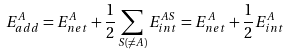<formula> <loc_0><loc_0><loc_500><loc_500>E _ { a d d } ^ { A } = E _ { n e t } ^ { A } + \frac { 1 } { 2 } \sum _ { S ( \not = A ) } E _ { i n t } ^ { A S } = E _ { n e t } ^ { A } + \frac { 1 } { 2 } E _ { i n t } ^ { A }</formula> 